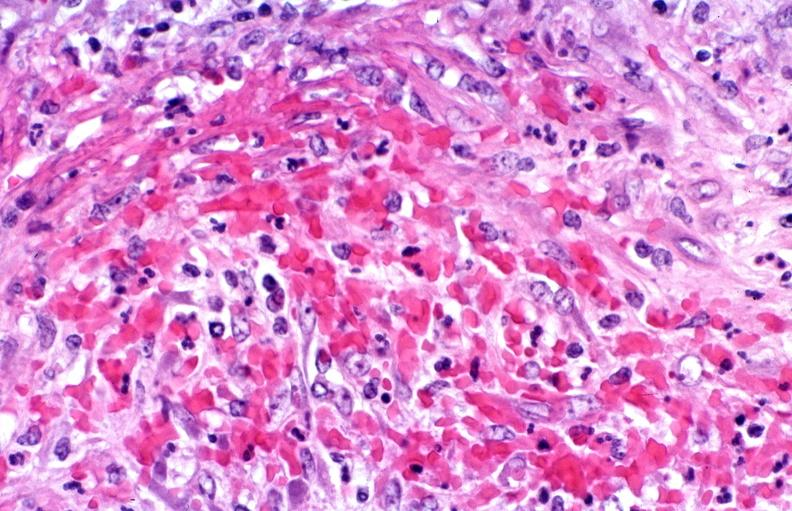s cardiovascular present?
Answer the question using a single word or phrase. Yes 